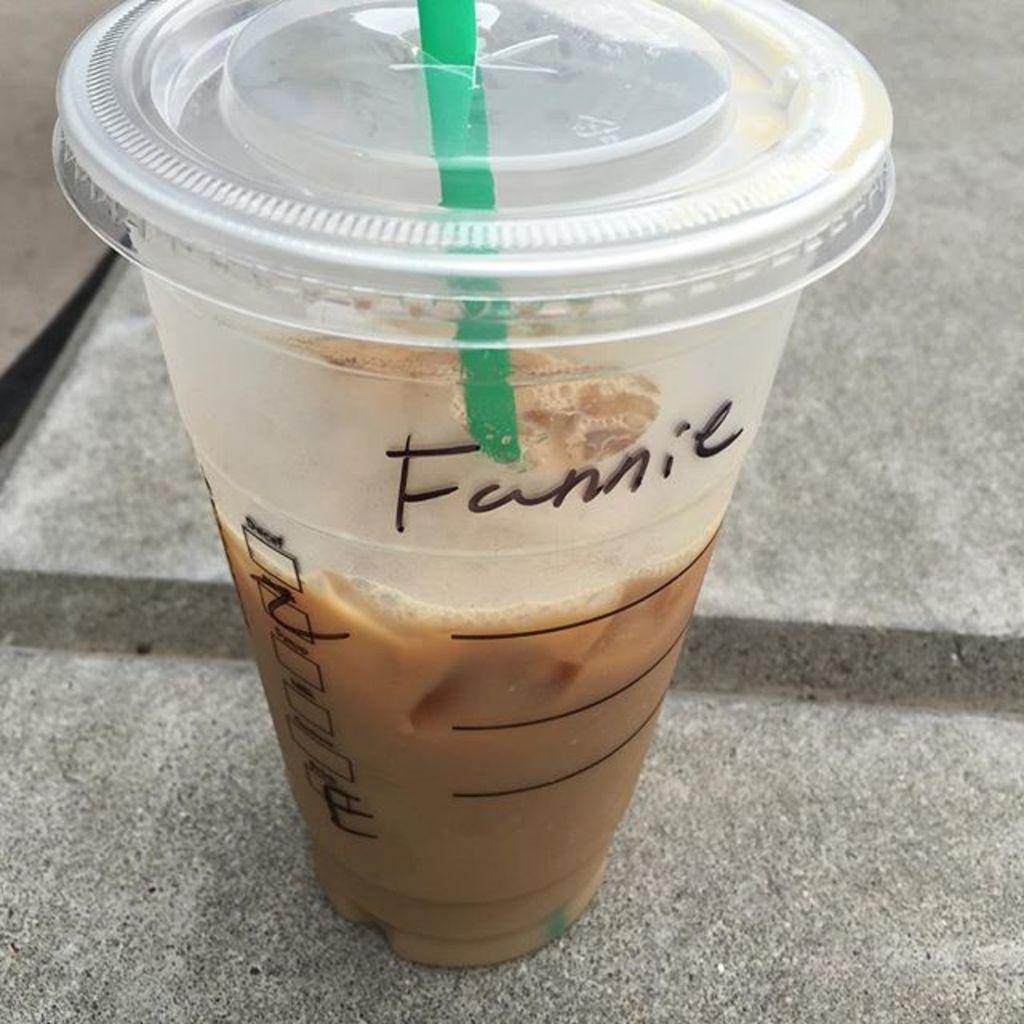Describe this image in one or two sentences. In this picture we can see a glass of drink and a straw in the front, there is some text on this glass. 